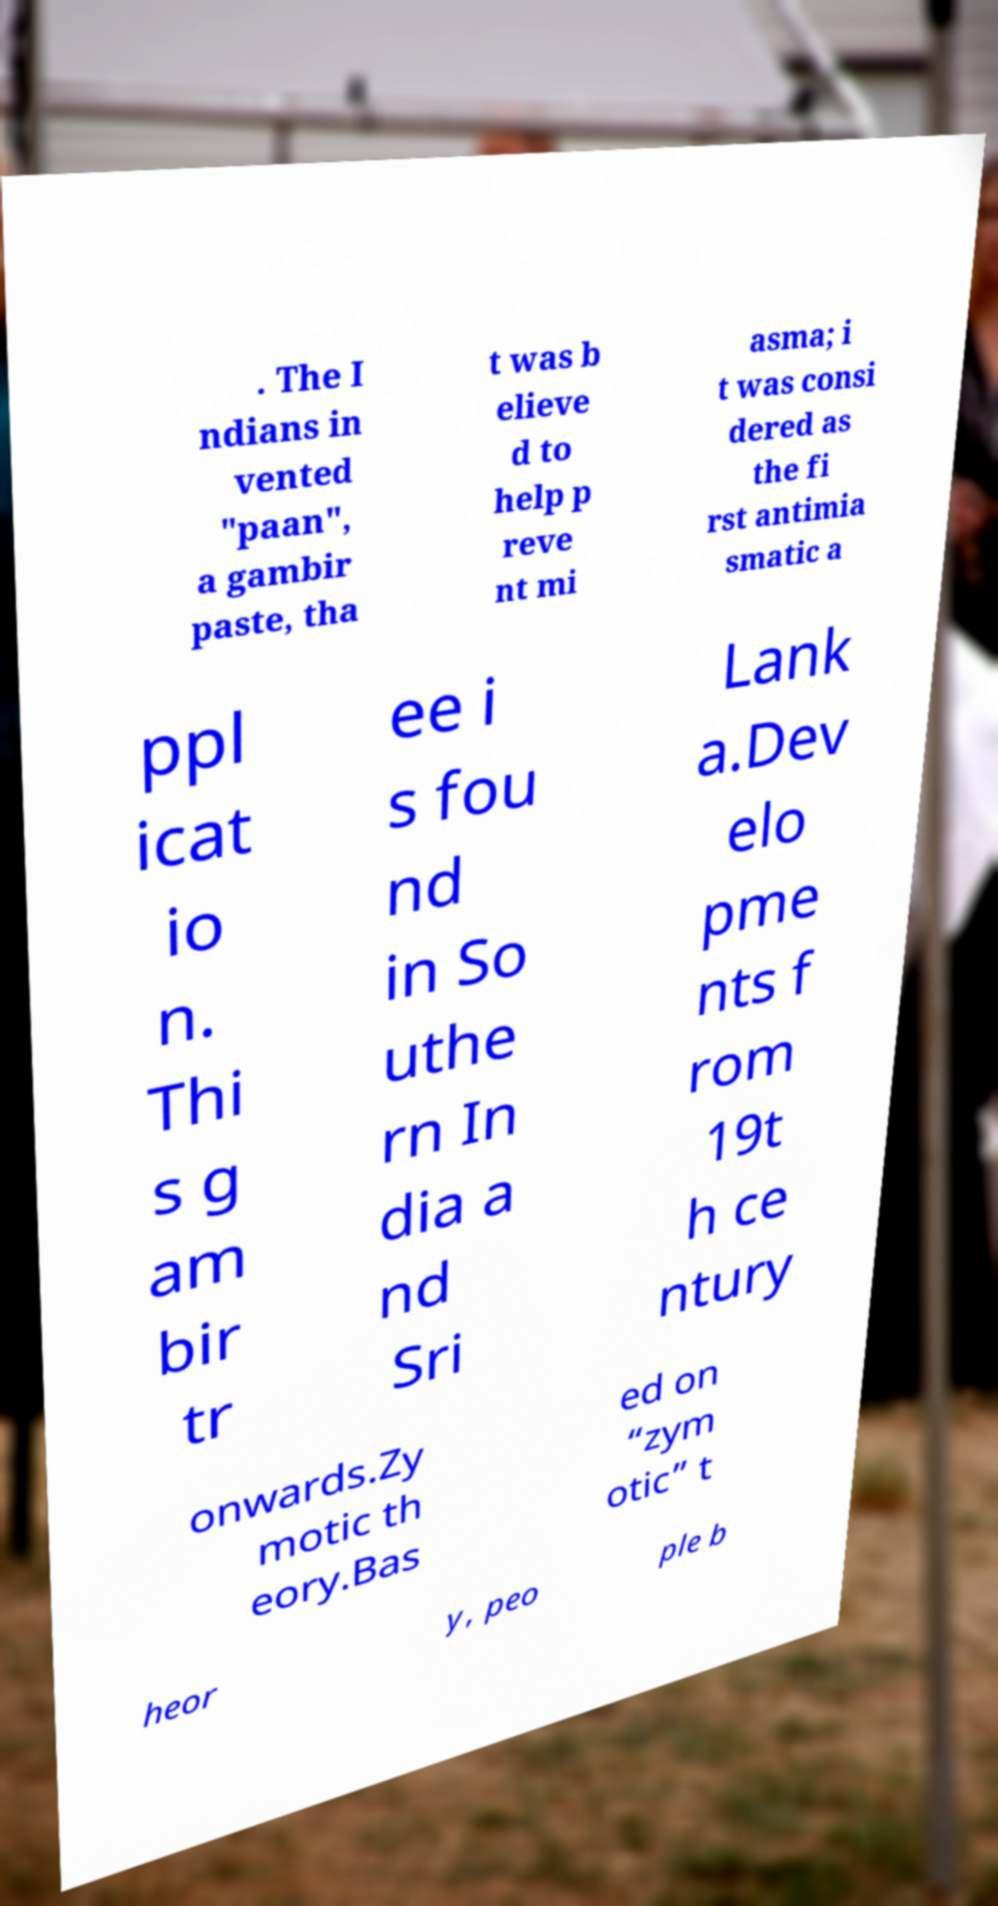I need the written content from this picture converted into text. Can you do that? . The I ndians in vented "paan", a gambir paste, tha t was b elieve d to help p reve nt mi asma; i t was consi dered as the fi rst antimia smatic a ppl icat io n. Thi s g am bir tr ee i s fou nd in So uthe rn In dia a nd Sri Lank a.Dev elo pme nts f rom 19t h ce ntury onwards.Zy motic th eory.Bas ed on “zym otic” t heor y, peo ple b 